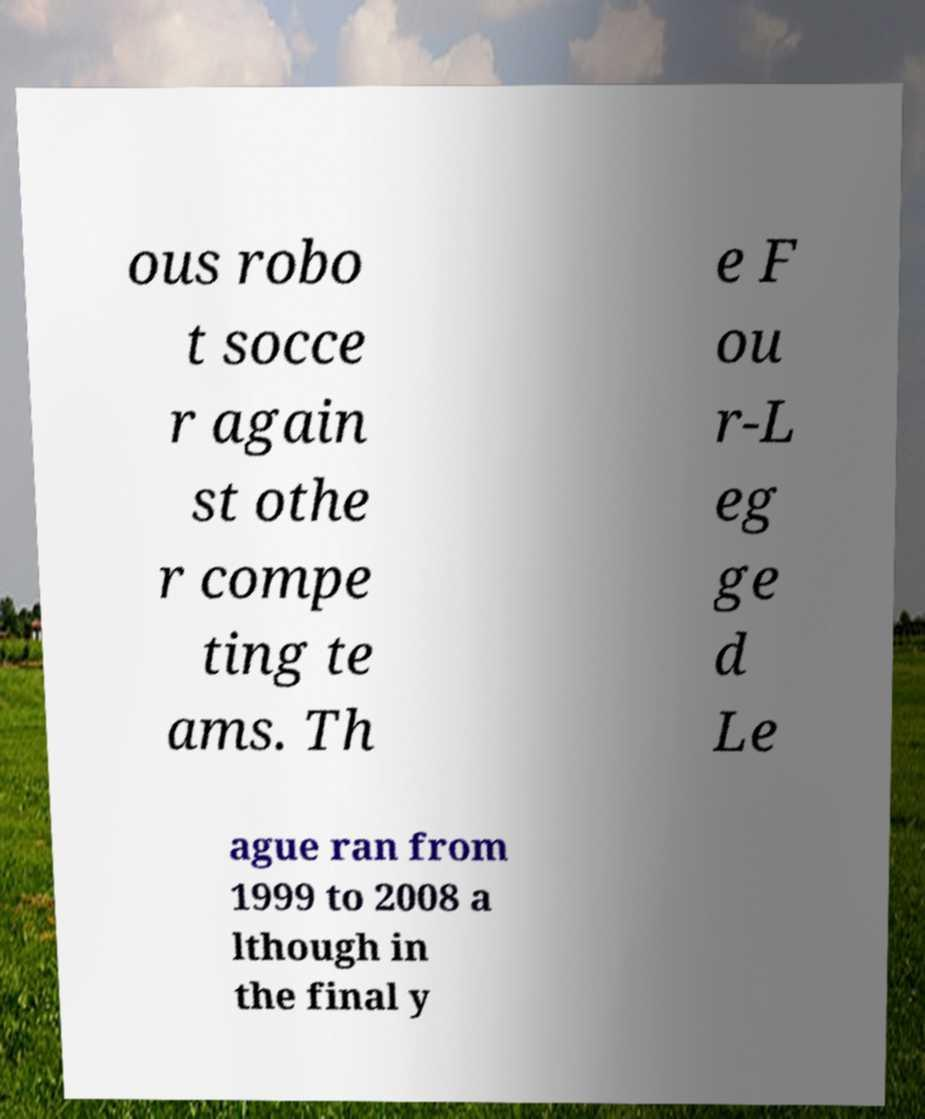Could you extract and type out the text from this image? ous robo t socce r again st othe r compe ting te ams. Th e F ou r-L eg ge d Le ague ran from 1999 to 2008 a lthough in the final y 